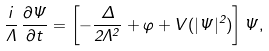Convert formula to latex. <formula><loc_0><loc_0><loc_500><loc_500>\frac { i } { \Lambda } \, \frac { \partial \Psi } { \partial t } = \left [ - \frac { \Delta } { 2 \Lambda ^ { 2 } } + \varphi + V ( | \Psi | ^ { 2 } ) \right ] \Psi ,</formula> 